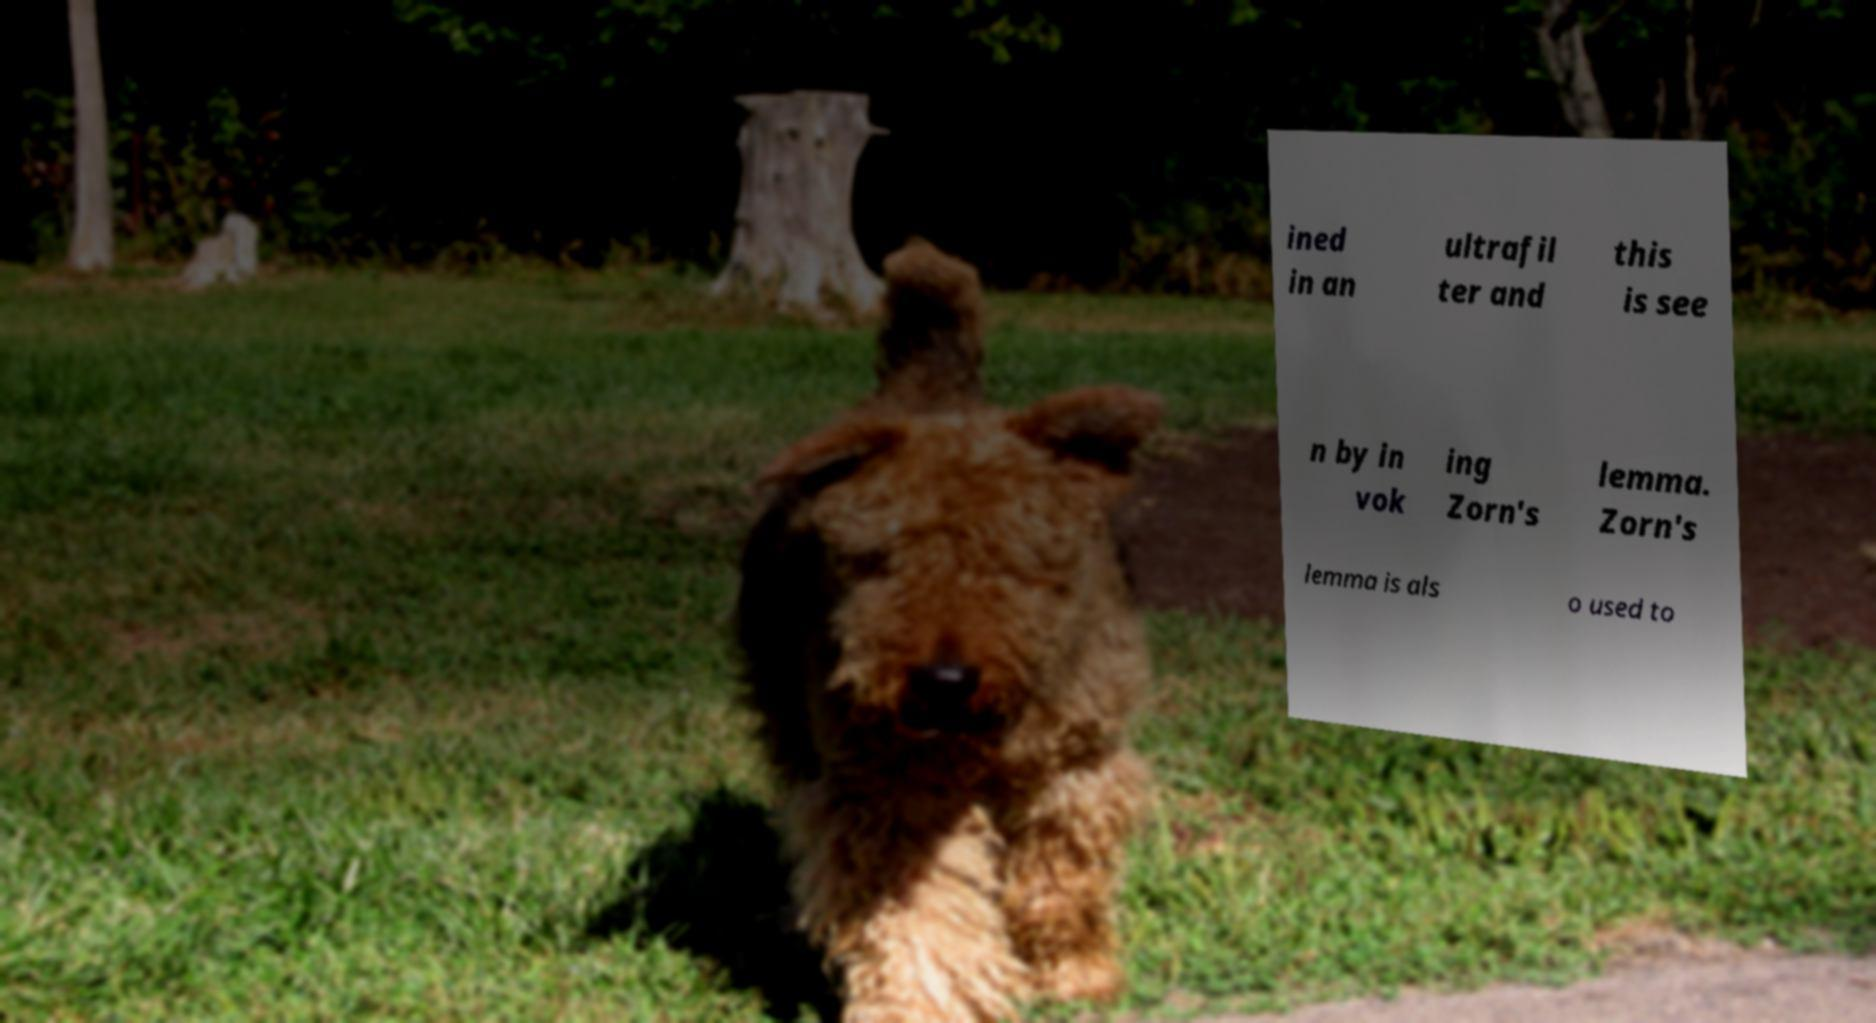Can you read and provide the text displayed in the image?This photo seems to have some interesting text. Can you extract and type it out for me? ined in an ultrafil ter and this is see n by in vok ing Zorn's lemma. Zorn's lemma is als o used to 